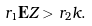Convert formula to latex. <formula><loc_0><loc_0><loc_500><loc_500>r _ { 1 } { \mathbf E } Z > r _ { 2 } k .</formula> 